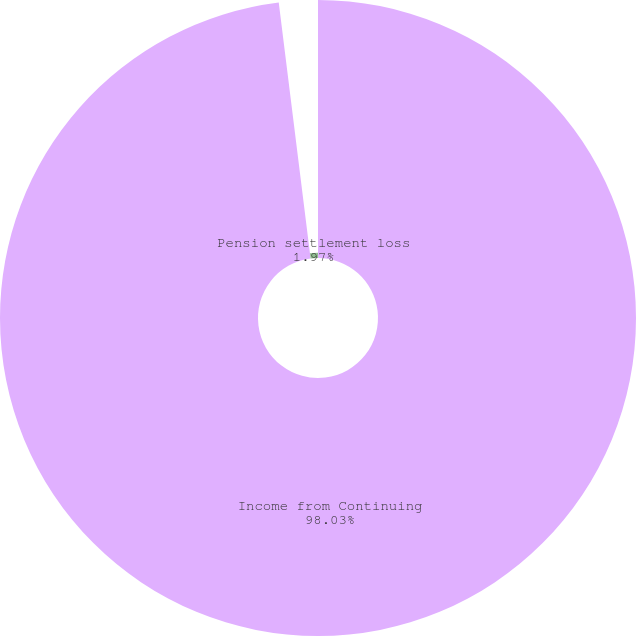<chart> <loc_0><loc_0><loc_500><loc_500><pie_chart><fcel>Income from Continuing<fcel>Pension settlement loss<nl><fcel>98.03%<fcel>1.97%<nl></chart> 